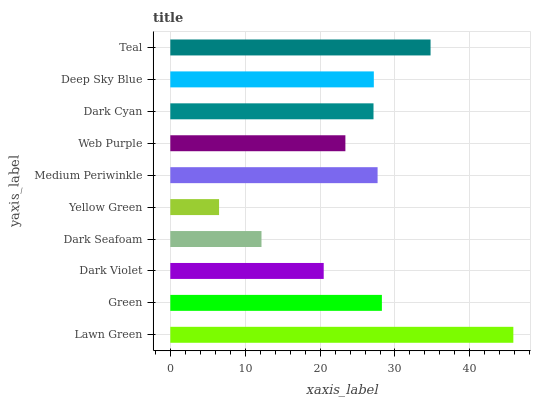Is Yellow Green the minimum?
Answer yes or no. Yes. Is Lawn Green the maximum?
Answer yes or no. Yes. Is Green the minimum?
Answer yes or no. No. Is Green the maximum?
Answer yes or no. No. Is Lawn Green greater than Green?
Answer yes or no. Yes. Is Green less than Lawn Green?
Answer yes or no. Yes. Is Green greater than Lawn Green?
Answer yes or no. No. Is Lawn Green less than Green?
Answer yes or no. No. Is Deep Sky Blue the high median?
Answer yes or no. Yes. Is Dark Cyan the low median?
Answer yes or no. Yes. Is Yellow Green the high median?
Answer yes or no. No. Is Medium Periwinkle the low median?
Answer yes or no. No. 